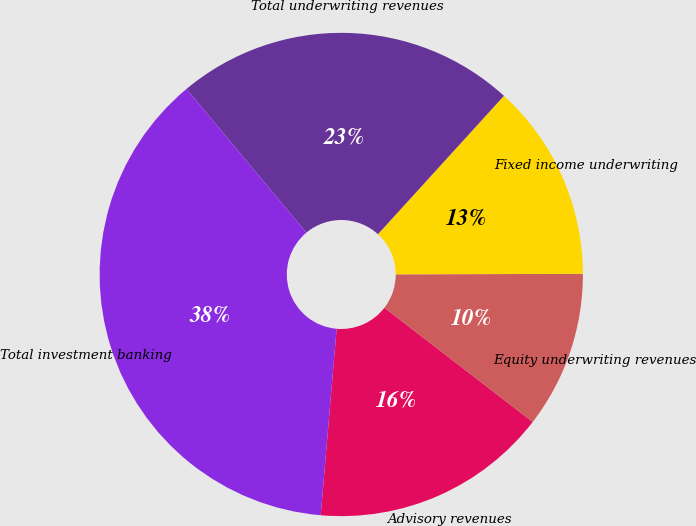Convert chart. <chart><loc_0><loc_0><loc_500><loc_500><pie_chart><fcel>Advisory revenues<fcel>Equity underwriting revenues<fcel>Fixed income underwriting<fcel>Total underwriting revenues<fcel>Total investment banking<nl><fcel>15.91%<fcel>10.49%<fcel>13.2%<fcel>22.82%<fcel>37.58%<nl></chart> 